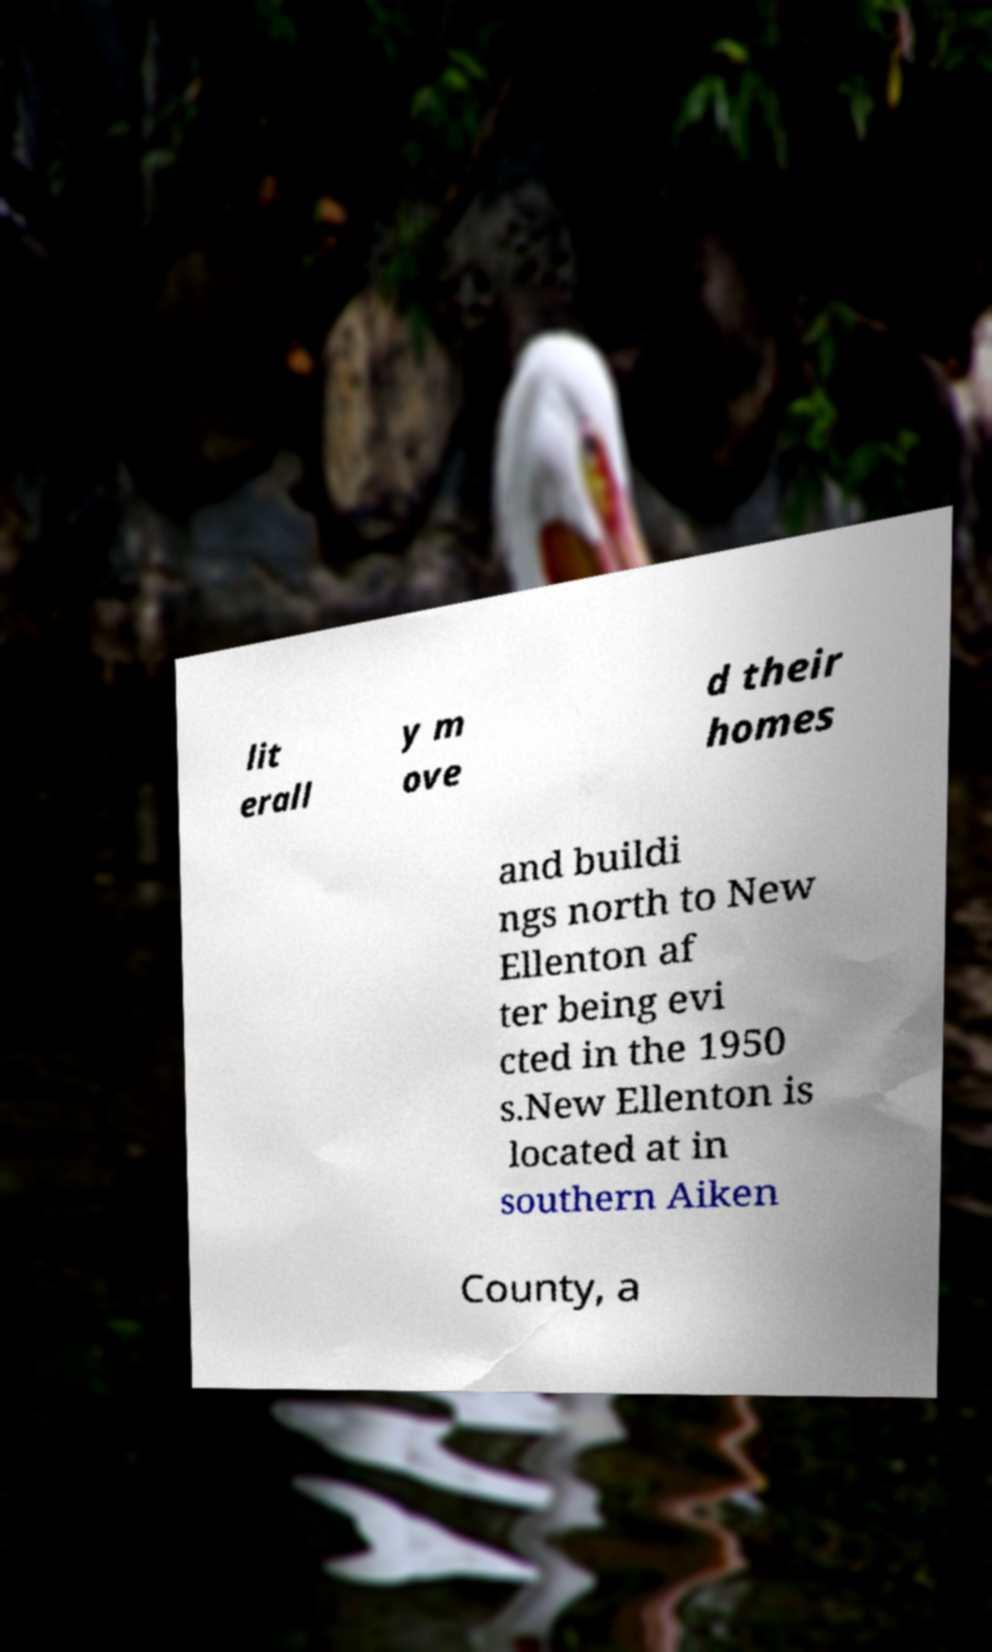Can you read and provide the text displayed in the image?This photo seems to have some interesting text. Can you extract and type it out for me? lit erall y m ove d their homes and buildi ngs north to New Ellenton af ter being evi cted in the 1950 s.New Ellenton is located at in southern Aiken County, a 